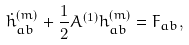Convert formula to latex. <formula><loc_0><loc_0><loc_500><loc_500>\dot { h } ^ { ( m ) } _ { a b } + \frac { 1 } { 2 } A ^ { ( 1 ) } h ^ { ( m ) } _ { a b } = F _ { a b } ,</formula> 